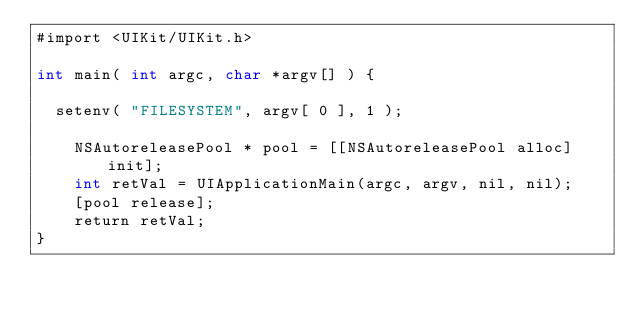<code> <loc_0><loc_0><loc_500><loc_500><_ObjectiveC_>#import <UIKit/UIKit.h>

int main( int argc, char *argv[] ) {

	setenv( "FILESYSTEM", argv[ 0 ], 1 );

    NSAutoreleasePool * pool = [[NSAutoreleasePool alloc] init];
    int retVal = UIApplicationMain(argc, argv, nil, nil);
    [pool release];
    return retVal;
}
</code> 